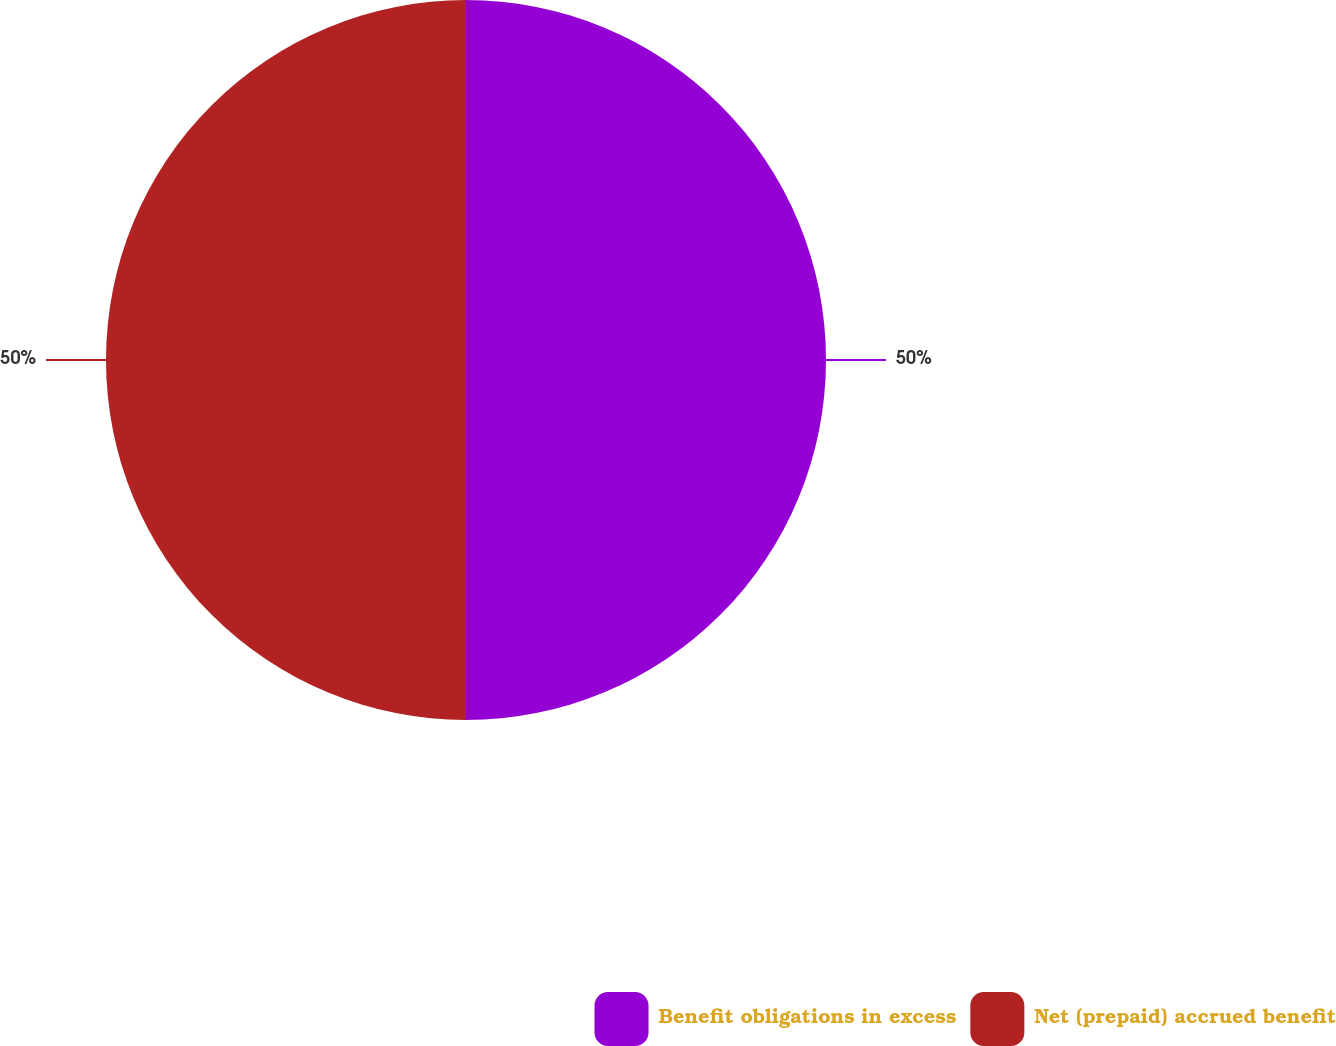Convert chart. <chart><loc_0><loc_0><loc_500><loc_500><pie_chart><fcel>Benefit obligations in excess<fcel>Net (prepaid) accrued benefit<nl><fcel>50.0%<fcel>50.0%<nl></chart> 